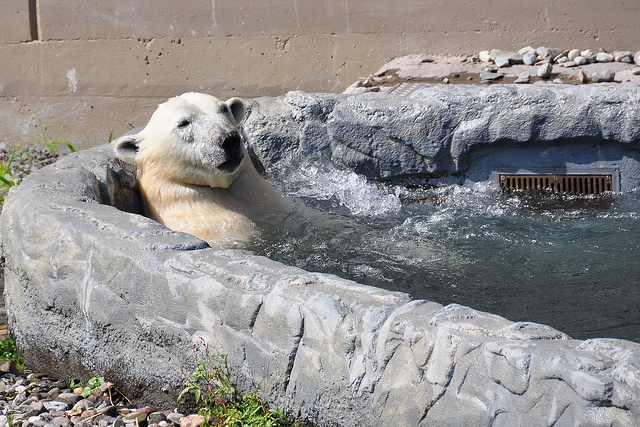Describe the objects in this image and their specific colors. I can see a bear in gray, lightgray, darkgray, and black tones in this image. 